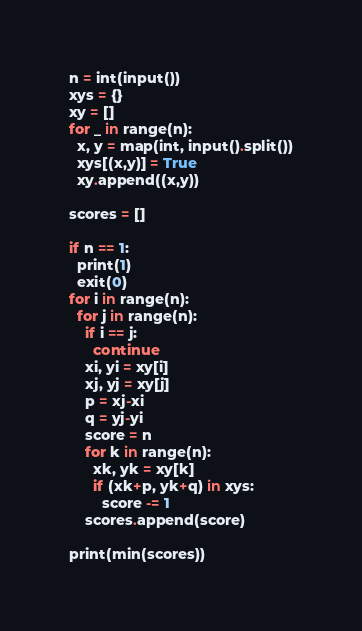<code> <loc_0><loc_0><loc_500><loc_500><_Python_>n = int(input())
xys = {}
xy = []
for _ in range(n):
  x, y = map(int, input().split())
  xys[(x,y)] = True
  xy.append((x,y))

scores = []

if n == 1:
  print(1)
  exit(0)
for i in range(n):
  for j in range(n):
    if i == j:
      continue
    xi, yi = xy[i]
    xj, yj = xy[j]
    p = xj-xi
    q = yj-yi
    score = n
    for k in range(n):
      xk, yk = xy[k]
      if (xk+p, yk+q) in xys:
        score -= 1
    scores.append(score)

print(min(scores))
</code> 